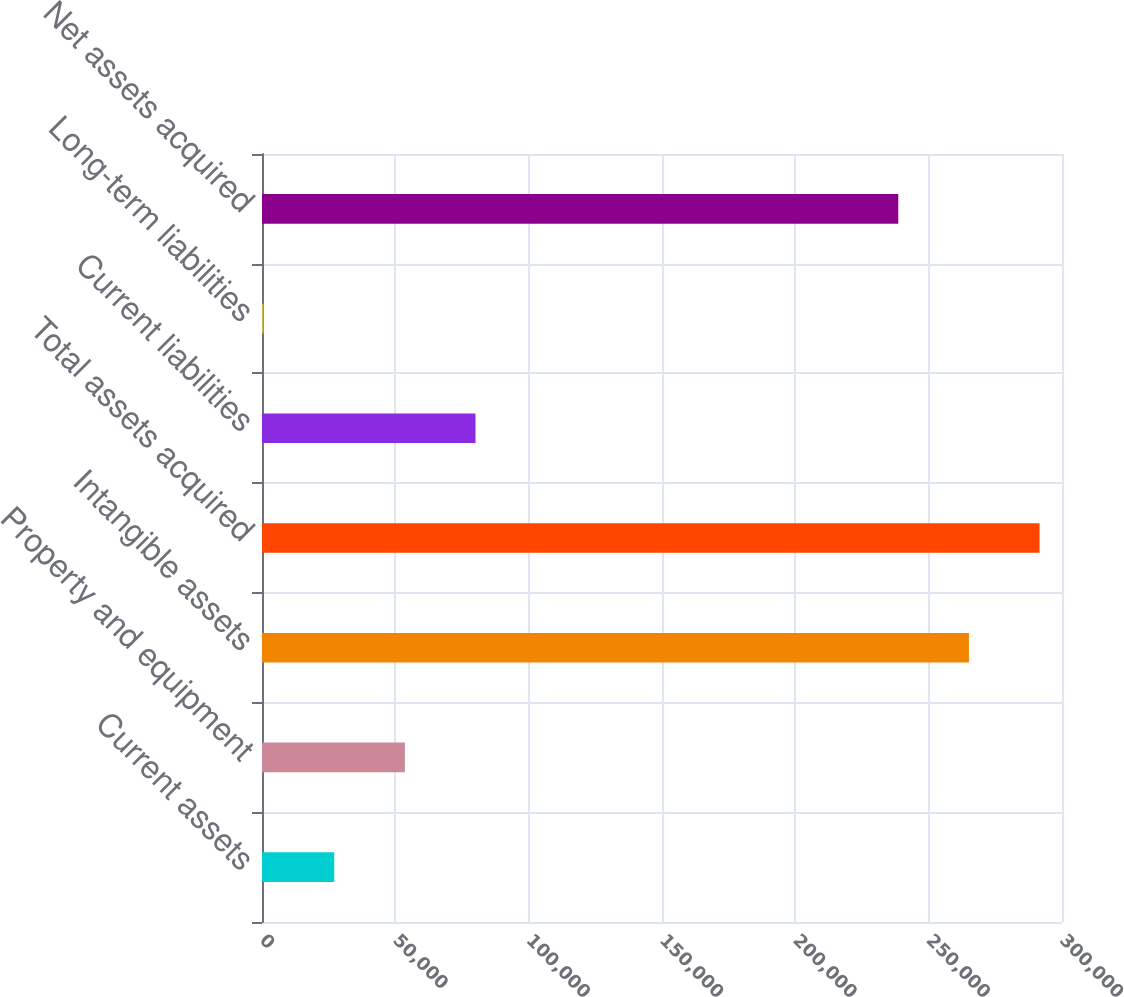<chart> <loc_0><loc_0><loc_500><loc_500><bar_chart><fcel>Current assets<fcel>Property and equipment<fcel>Intangible assets<fcel>Total assets acquired<fcel>Current liabilities<fcel>Long-term liabilities<fcel>Net assets acquired<nl><fcel>27087.9<fcel>53575.8<fcel>265098<fcel>291586<fcel>80063.7<fcel>600<fcel>238610<nl></chart> 